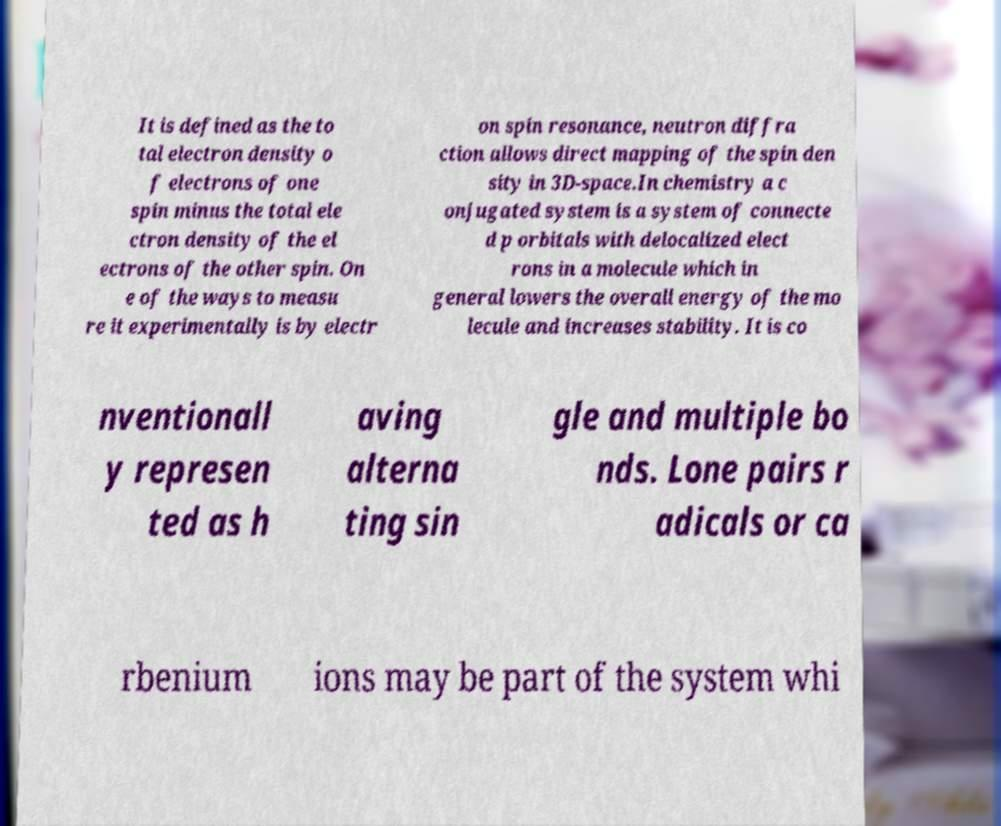Please read and relay the text visible in this image. What does it say? It is defined as the to tal electron density o f electrons of one spin minus the total ele ctron density of the el ectrons of the other spin. On e of the ways to measu re it experimentally is by electr on spin resonance, neutron diffra ction allows direct mapping of the spin den sity in 3D-space.In chemistry a c onjugated system is a system of connecte d p orbitals with delocalized elect rons in a molecule which in general lowers the overall energy of the mo lecule and increases stability. It is co nventionall y represen ted as h aving alterna ting sin gle and multiple bo nds. Lone pairs r adicals or ca rbenium ions may be part of the system whi 